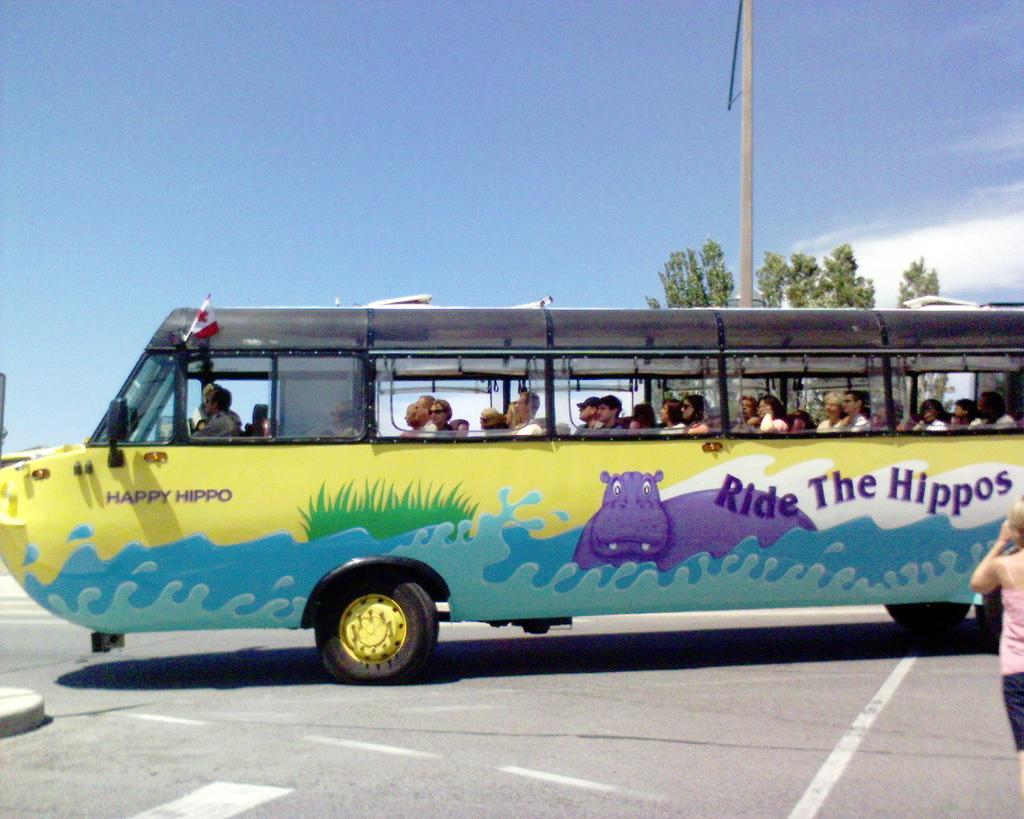<image>
Summarize the visual content of the image. People riding in a bus that says "Ride The Hippos". 